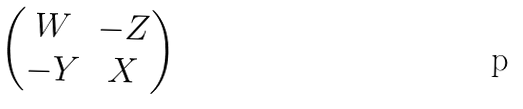Convert formula to latex. <formula><loc_0><loc_0><loc_500><loc_500>\begin{pmatrix} W & - Z \\ - Y & X \end{pmatrix}</formula> 